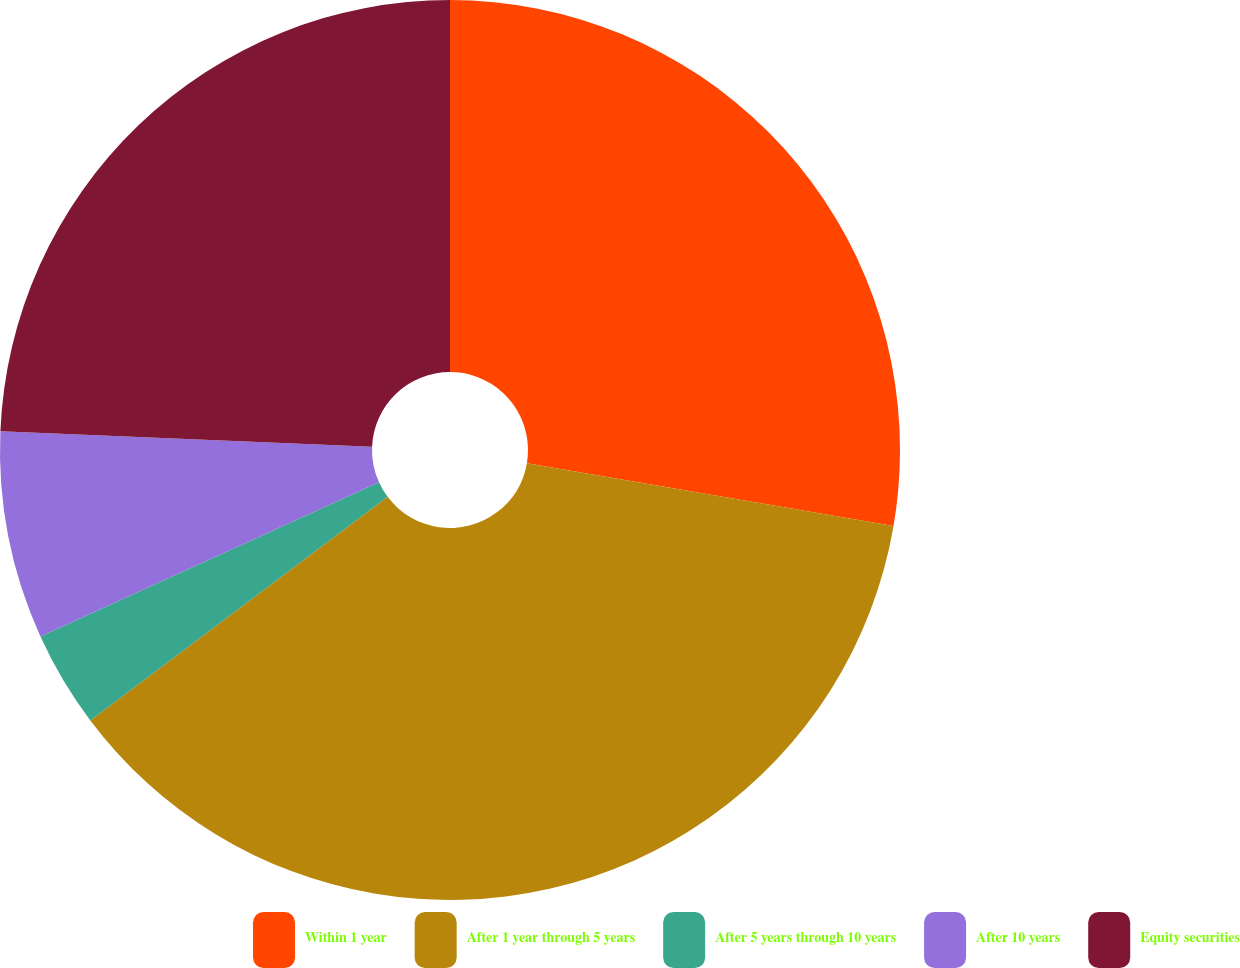Convert chart. <chart><loc_0><loc_0><loc_500><loc_500><pie_chart><fcel>Within 1 year<fcel>After 1 year through 5 years<fcel>After 5 years through 10 years<fcel>After 10 years<fcel>Equity securities<nl><fcel>27.7%<fcel>37.04%<fcel>3.46%<fcel>7.46%<fcel>24.34%<nl></chart> 